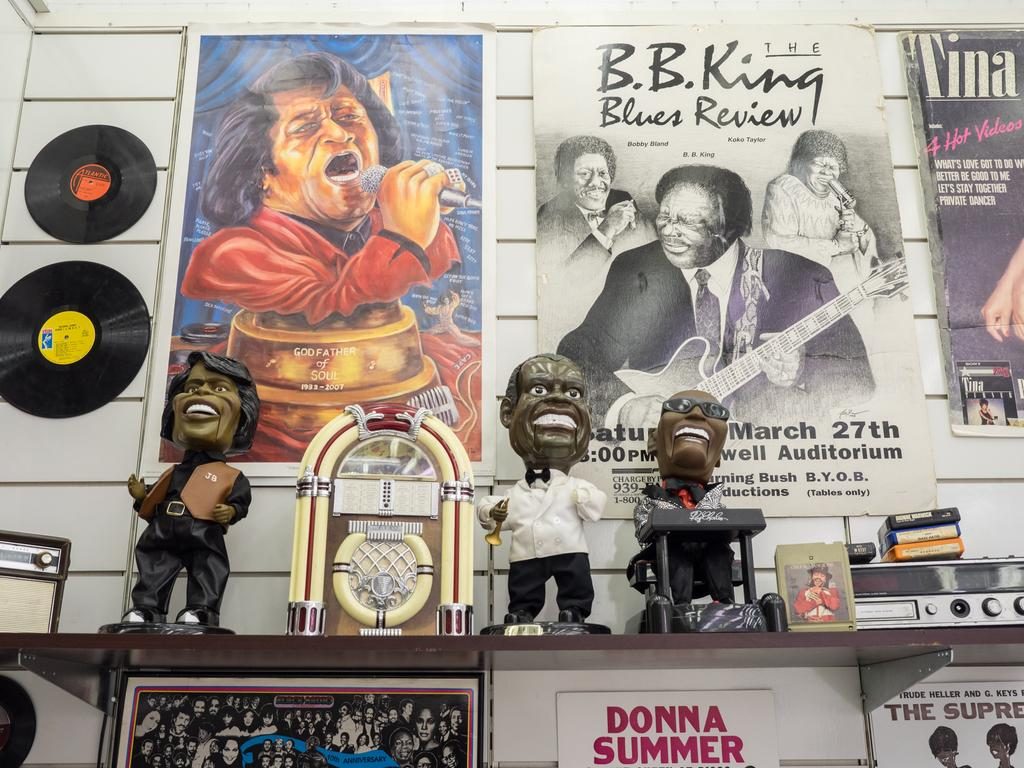What is hanging on the wall in the image? There are posters and photo frames on the wall. Are there any other objects on the wall besides posters and photo frames? Yes, there are other objects on the wall. What can be seen on the wooden platform in the image? There are toys on the wooden platform. Are there any other objects on the wooden platform besides toys? Yes, there are other objects on the wooden platform. What type of bean is present on the wall in the image? There are no beans present on the wall or wooden platform in the image. Who is the representative of the toys on the wooden platform? The image does not provide information about a representative for the toys. 